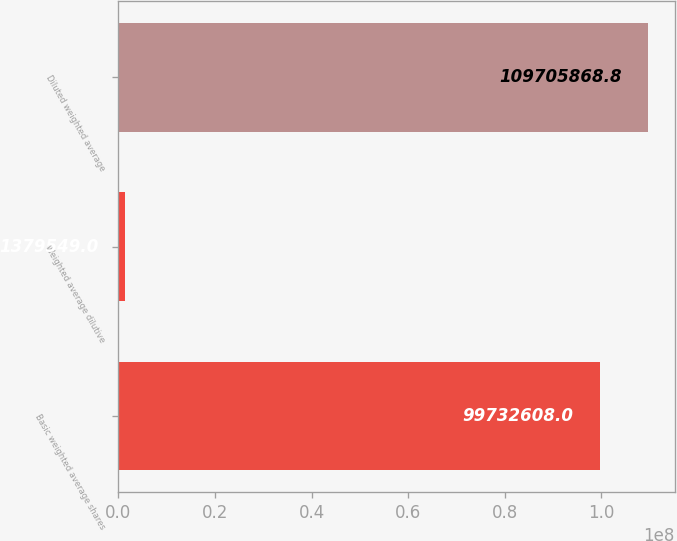Convert chart. <chart><loc_0><loc_0><loc_500><loc_500><bar_chart><fcel>Basic weighted average shares<fcel>Weighted average dilutive<fcel>Diluted weighted average<nl><fcel>9.97326e+07<fcel>1.37955e+06<fcel>1.09706e+08<nl></chart> 